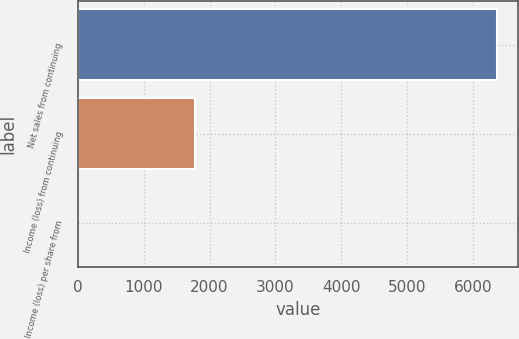Convert chart to OTSL. <chart><loc_0><loc_0><loc_500><loc_500><bar_chart><fcel>Net sales from continuing<fcel>Income (loss) from continuing<fcel>Income (loss) per share from<nl><fcel>6362.4<fcel>1779.4<fcel>3.01<nl></chart> 